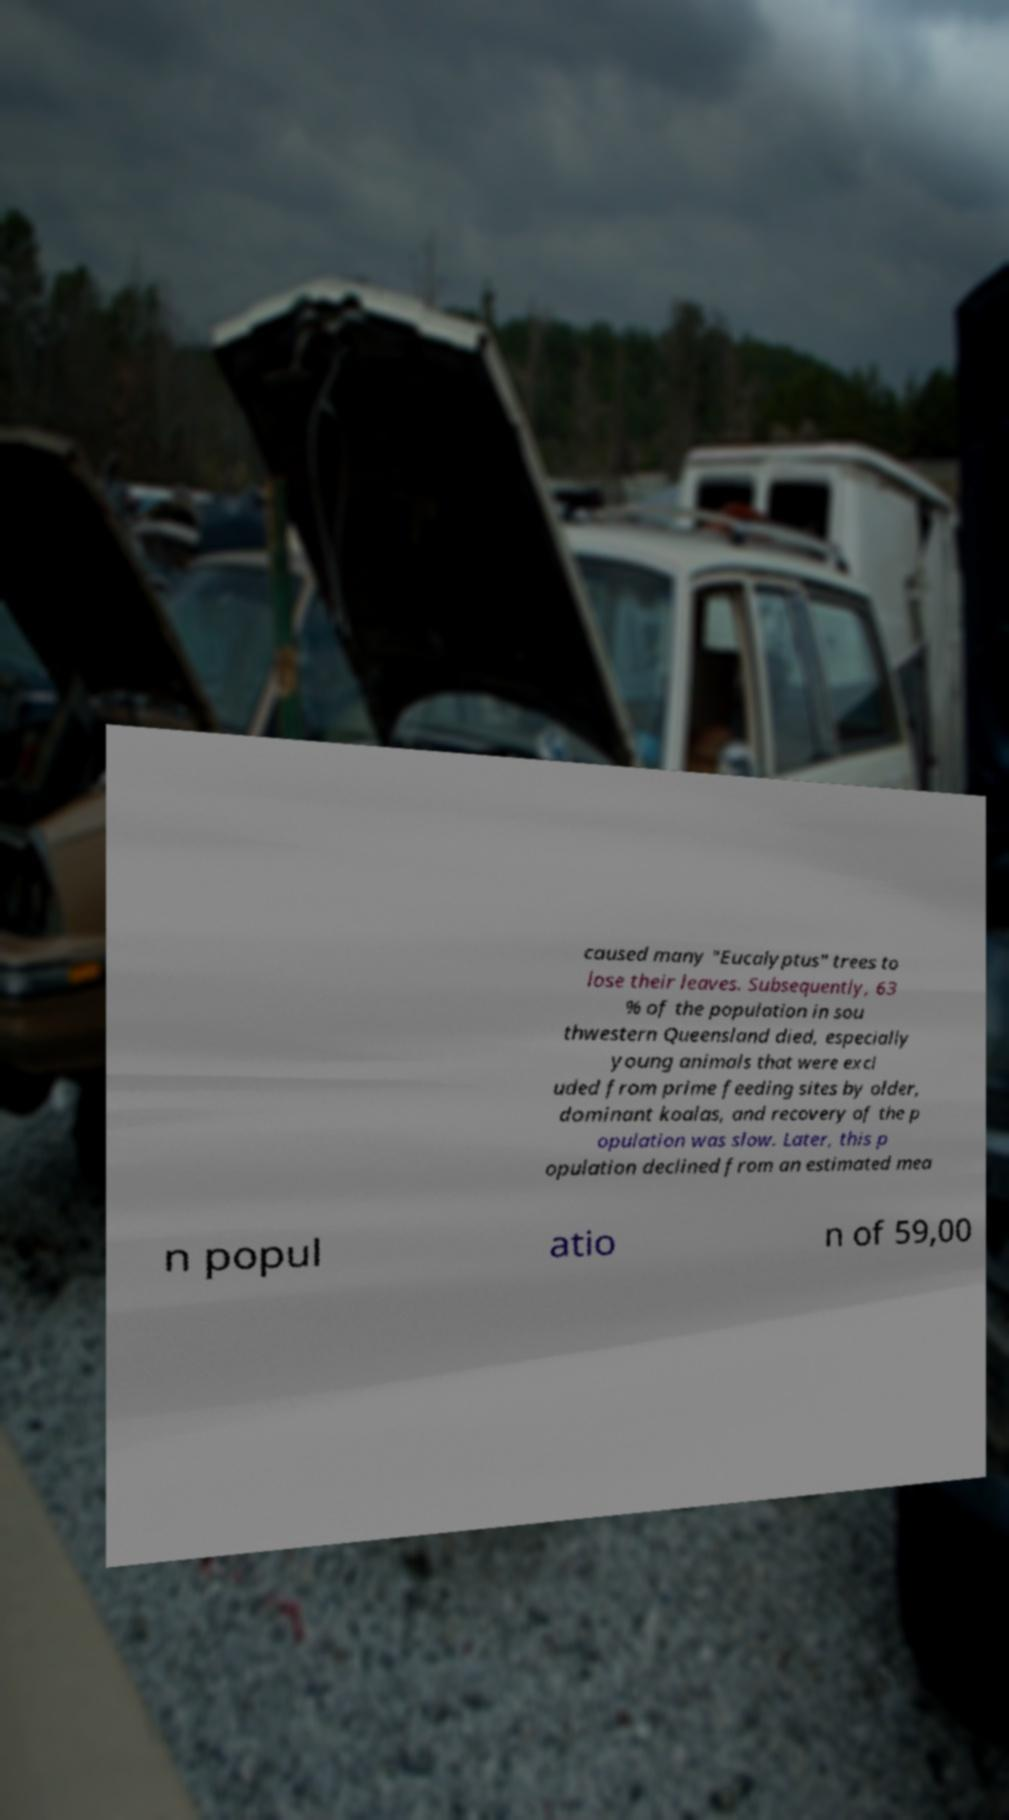I need the written content from this picture converted into text. Can you do that? caused many "Eucalyptus" trees to lose their leaves. Subsequently, 63 % of the population in sou thwestern Queensland died, especially young animals that were excl uded from prime feeding sites by older, dominant koalas, and recovery of the p opulation was slow. Later, this p opulation declined from an estimated mea n popul atio n of 59,00 